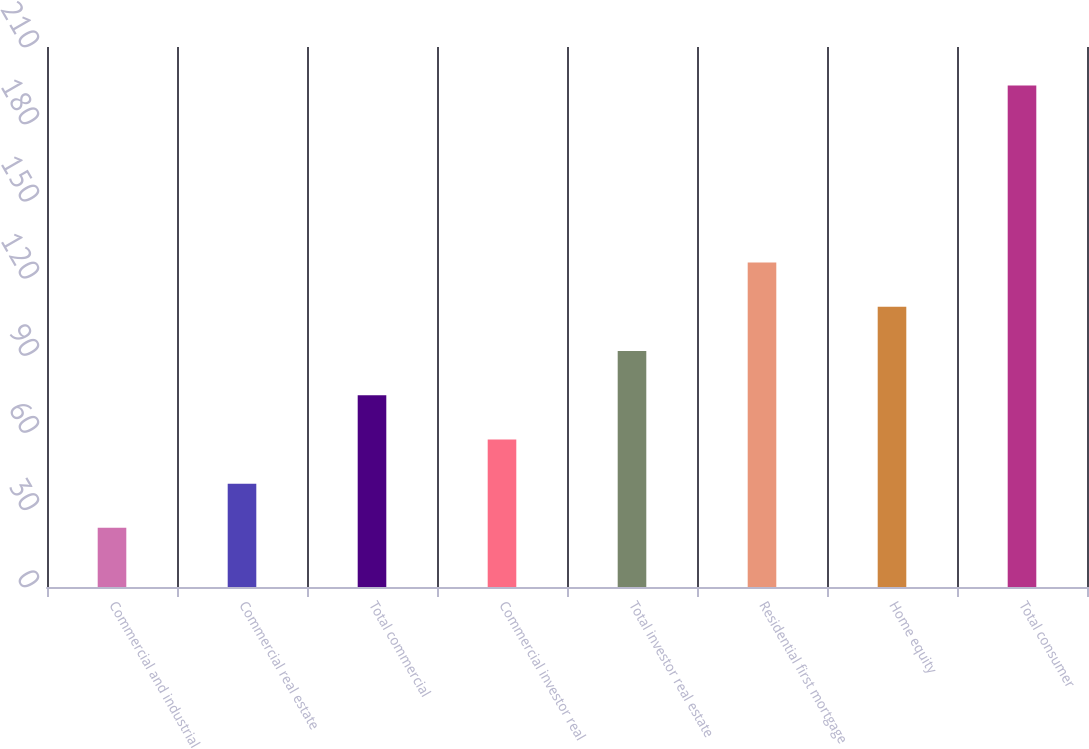Convert chart. <chart><loc_0><loc_0><loc_500><loc_500><bar_chart><fcel>Commercial and industrial<fcel>Commercial real estate<fcel>Total commercial<fcel>Commercial investor real<fcel>Total investor real estate<fcel>Residential first mortgage<fcel>Home equity<fcel>Total consumer<nl><fcel>23<fcel>40.2<fcel>74.6<fcel>57.4<fcel>91.8<fcel>126.2<fcel>109<fcel>195<nl></chart> 